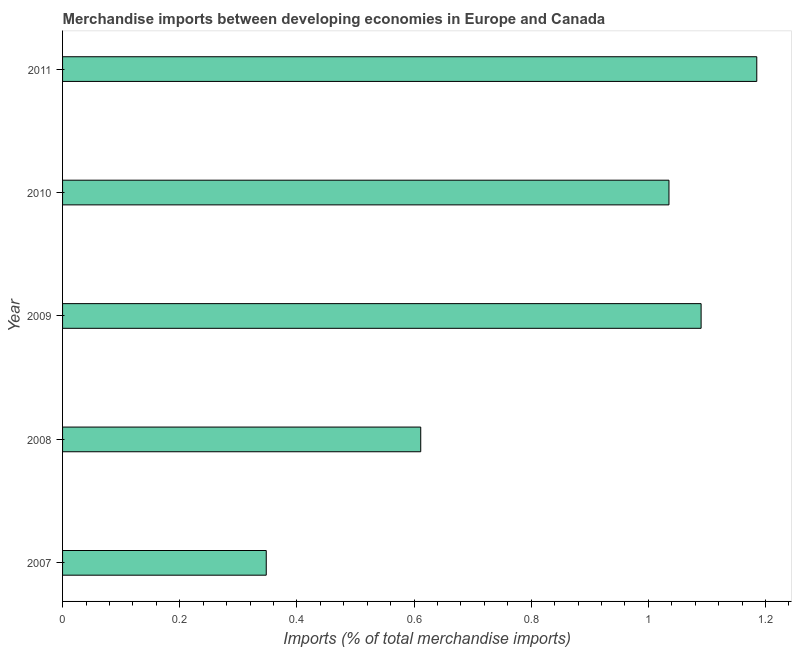Does the graph contain any zero values?
Offer a very short reply. No. Does the graph contain grids?
Offer a very short reply. No. What is the title of the graph?
Ensure brevity in your answer.  Merchandise imports between developing economies in Europe and Canada. What is the label or title of the X-axis?
Offer a very short reply. Imports (% of total merchandise imports). What is the merchandise imports in 2011?
Your answer should be compact. 1.19. Across all years, what is the maximum merchandise imports?
Give a very brief answer. 1.19. Across all years, what is the minimum merchandise imports?
Offer a very short reply. 0.35. In which year was the merchandise imports maximum?
Ensure brevity in your answer.  2011. What is the sum of the merchandise imports?
Make the answer very short. 4.27. What is the difference between the merchandise imports in 2008 and 2010?
Provide a succinct answer. -0.42. What is the average merchandise imports per year?
Give a very brief answer. 0.85. What is the median merchandise imports?
Keep it short and to the point. 1.04. In how many years, is the merchandise imports greater than 0.52 %?
Offer a terse response. 4. What is the ratio of the merchandise imports in 2007 to that in 2008?
Your answer should be very brief. 0.57. What is the difference between the highest and the second highest merchandise imports?
Keep it short and to the point. 0.1. Is the sum of the merchandise imports in 2007 and 2011 greater than the maximum merchandise imports across all years?
Your answer should be compact. Yes. What is the difference between the highest and the lowest merchandise imports?
Keep it short and to the point. 0.84. In how many years, is the merchandise imports greater than the average merchandise imports taken over all years?
Give a very brief answer. 3. What is the difference between two consecutive major ticks on the X-axis?
Give a very brief answer. 0.2. Are the values on the major ticks of X-axis written in scientific E-notation?
Make the answer very short. No. What is the Imports (% of total merchandise imports) of 2007?
Offer a very short reply. 0.35. What is the Imports (% of total merchandise imports) in 2008?
Provide a short and direct response. 0.61. What is the Imports (% of total merchandise imports) in 2009?
Your answer should be compact. 1.09. What is the Imports (% of total merchandise imports) of 2010?
Keep it short and to the point. 1.04. What is the Imports (% of total merchandise imports) of 2011?
Give a very brief answer. 1.19. What is the difference between the Imports (% of total merchandise imports) in 2007 and 2008?
Your answer should be very brief. -0.26. What is the difference between the Imports (% of total merchandise imports) in 2007 and 2009?
Make the answer very short. -0.74. What is the difference between the Imports (% of total merchandise imports) in 2007 and 2010?
Your response must be concise. -0.69. What is the difference between the Imports (% of total merchandise imports) in 2007 and 2011?
Your answer should be compact. -0.84. What is the difference between the Imports (% of total merchandise imports) in 2008 and 2009?
Provide a short and direct response. -0.48. What is the difference between the Imports (% of total merchandise imports) in 2008 and 2010?
Offer a terse response. -0.42. What is the difference between the Imports (% of total merchandise imports) in 2008 and 2011?
Make the answer very short. -0.57. What is the difference between the Imports (% of total merchandise imports) in 2009 and 2010?
Give a very brief answer. 0.05. What is the difference between the Imports (% of total merchandise imports) in 2009 and 2011?
Offer a very short reply. -0.1. What is the difference between the Imports (% of total merchandise imports) in 2010 and 2011?
Your answer should be very brief. -0.15. What is the ratio of the Imports (% of total merchandise imports) in 2007 to that in 2008?
Offer a very short reply. 0.57. What is the ratio of the Imports (% of total merchandise imports) in 2007 to that in 2009?
Offer a terse response. 0.32. What is the ratio of the Imports (% of total merchandise imports) in 2007 to that in 2010?
Your answer should be very brief. 0.34. What is the ratio of the Imports (% of total merchandise imports) in 2007 to that in 2011?
Your response must be concise. 0.29. What is the ratio of the Imports (% of total merchandise imports) in 2008 to that in 2009?
Your answer should be compact. 0.56. What is the ratio of the Imports (% of total merchandise imports) in 2008 to that in 2010?
Keep it short and to the point. 0.59. What is the ratio of the Imports (% of total merchandise imports) in 2008 to that in 2011?
Your response must be concise. 0.52. What is the ratio of the Imports (% of total merchandise imports) in 2009 to that in 2010?
Your answer should be very brief. 1.05. What is the ratio of the Imports (% of total merchandise imports) in 2010 to that in 2011?
Your answer should be very brief. 0.87. 